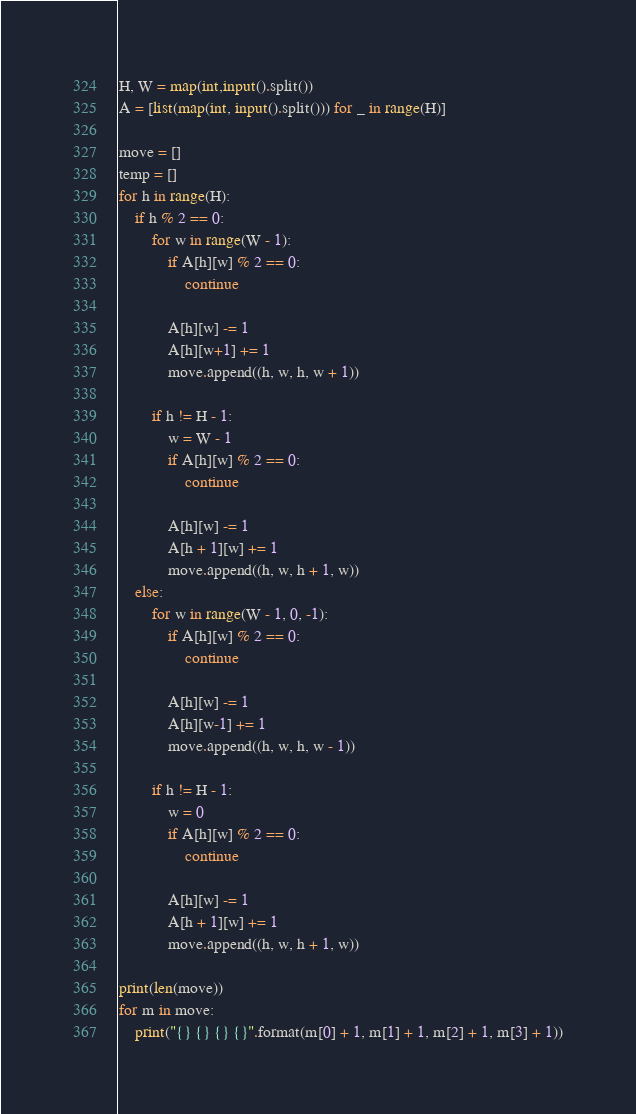<code> <loc_0><loc_0><loc_500><loc_500><_Python_>H, W = map(int,input().split())
A = [list(map(int, input().split())) for _ in range(H)]

move = []
temp = []
for h in range(H):
    if h % 2 == 0:
        for w in range(W - 1):
            if A[h][w] % 2 == 0:
                continue
            
            A[h][w] -= 1
            A[h][w+1] += 1
            move.append((h, w, h, w + 1))
        
        if h != H - 1:
            w = W - 1
            if A[h][w] % 2 == 0:
                continue
            
            A[h][w] -= 1
            A[h + 1][w] += 1
            move.append((h, w, h + 1, w))
    else:
        for w in range(W - 1, 0, -1):
            if A[h][w] % 2 == 0:
                continue
            
            A[h][w] -= 1
            A[h][w-1] += 1
            move.append((h, w, h, w - 1))
        
        if h != H - 1:
            w = 0
            if A[h][w] % 2 == 0:
                continue
            
            A[h][w] -= 1
            A[h + 1][w] += 1
            move.append((h, w, h + 1, w))

print(len(move))
for m in move:
    print("{} {} {} {}".format(m[0] + 1, m[1] + 1, m[2] + 1, m[3] + 1))
</code> 